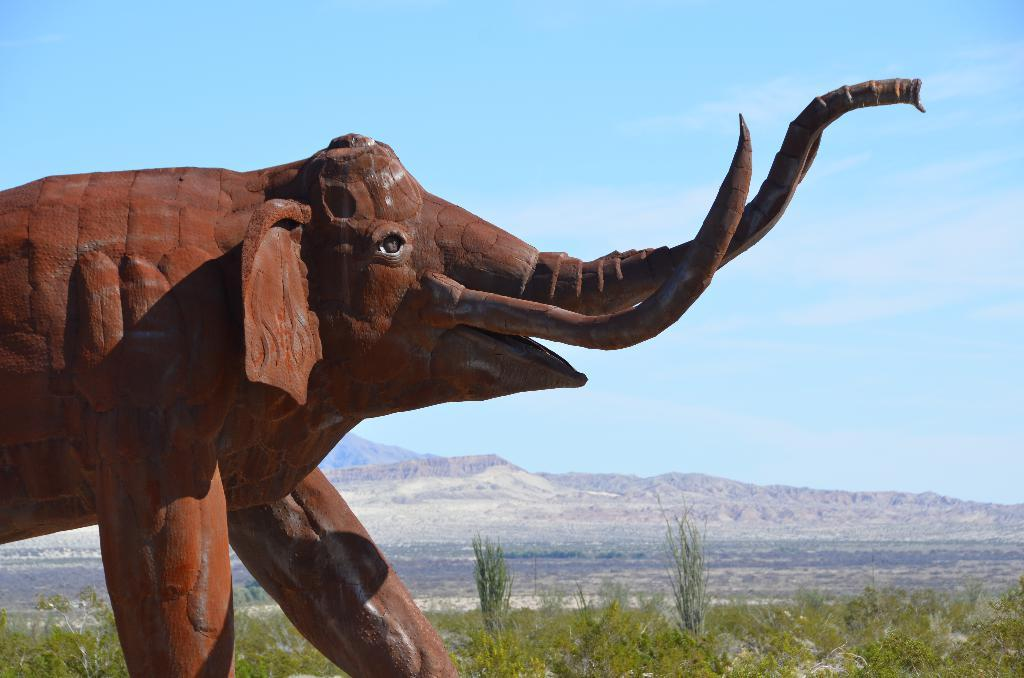What type of sculpture can be seen in the image? There is a sculpture of an elephant in the image. What other elements are present in the image besides the sculpture? There are plants, trees, hills, and the sky visible in the image. Can you describe the natural elements in the image? There are plants, trees, and hills in the image, which suggest a natural setting. What is visible in the background of the image? The sky is visible in the background of the image. What rate is the hose being used at in the image? There is no hose present in the image, so it is not possible to determine the rate at which it might be used. 